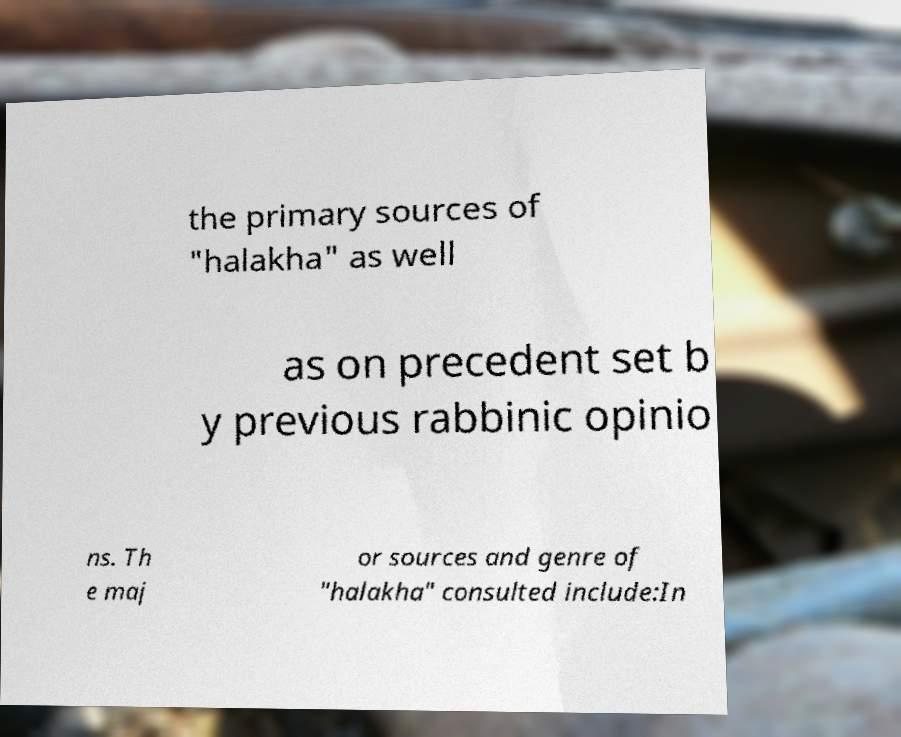For documentation purposes, I need the text within this image transcribed. Could you provide that? the primary sources of "halakha" as well as on precedent set b y previous rabbinic opinio ns. Th e maj or sources and genre of "halakha" consulted include:In 